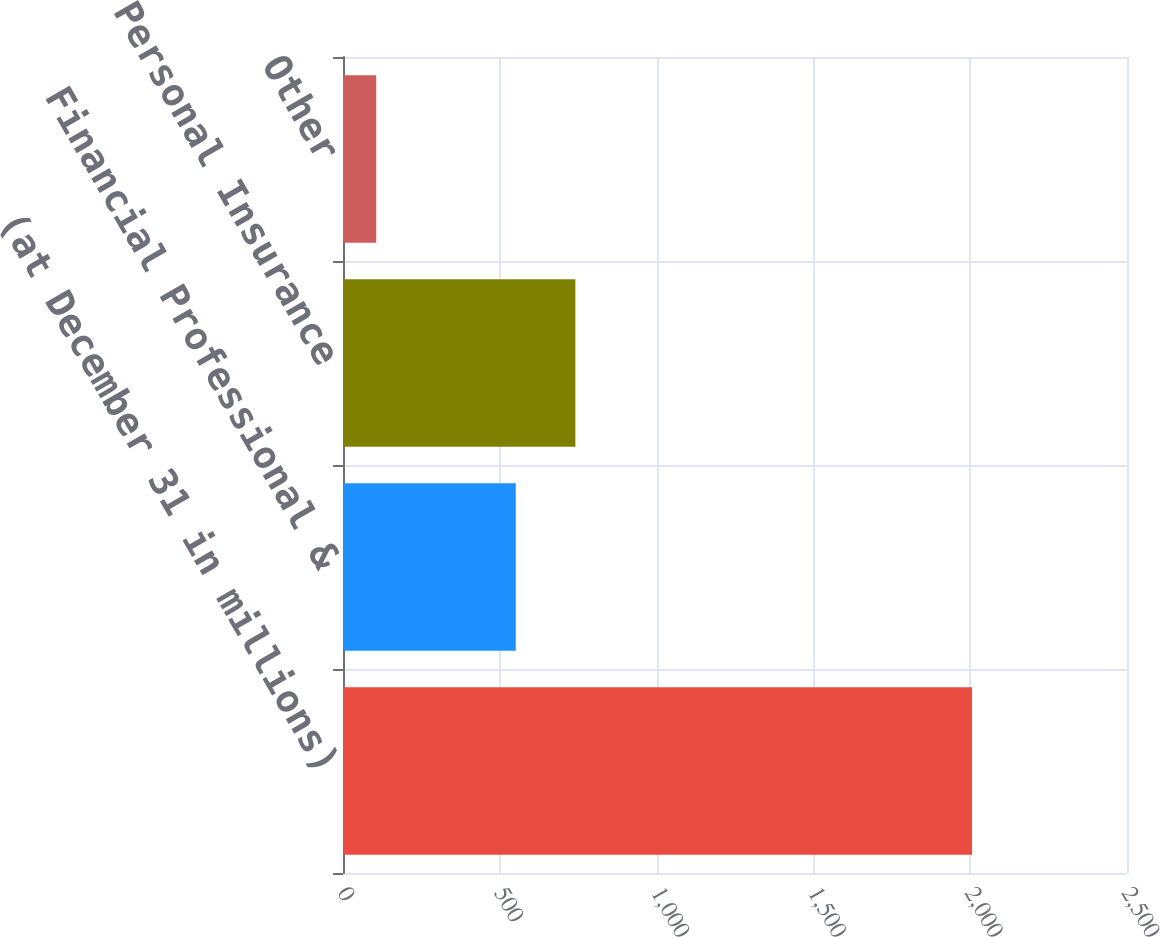<chart> <loc_0><loc_0><loc_500><loc_500><bar_chart><fcel>(at December 31 in millions)<fcel>Financial Professional &<fcel>Personal Insurance<fcel>Other<nl><fcel>2006<fcel>551<fcel>741<fcel>106<nl></chart> 